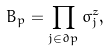<formula> <loc_0><loc_0><loc_500><loc_500>B _ { p } = \prod _ { j \in \partial p } \sigma _ { j } ^ { z } ,</formula> 